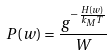Convert formula to latex. <formula><loc_0><loc_0><loc_500><loc_500>P ( w ) = \frac { g ^ { - \frac { H ( w ) } { k _ { M } T } } } { W }</formula> 